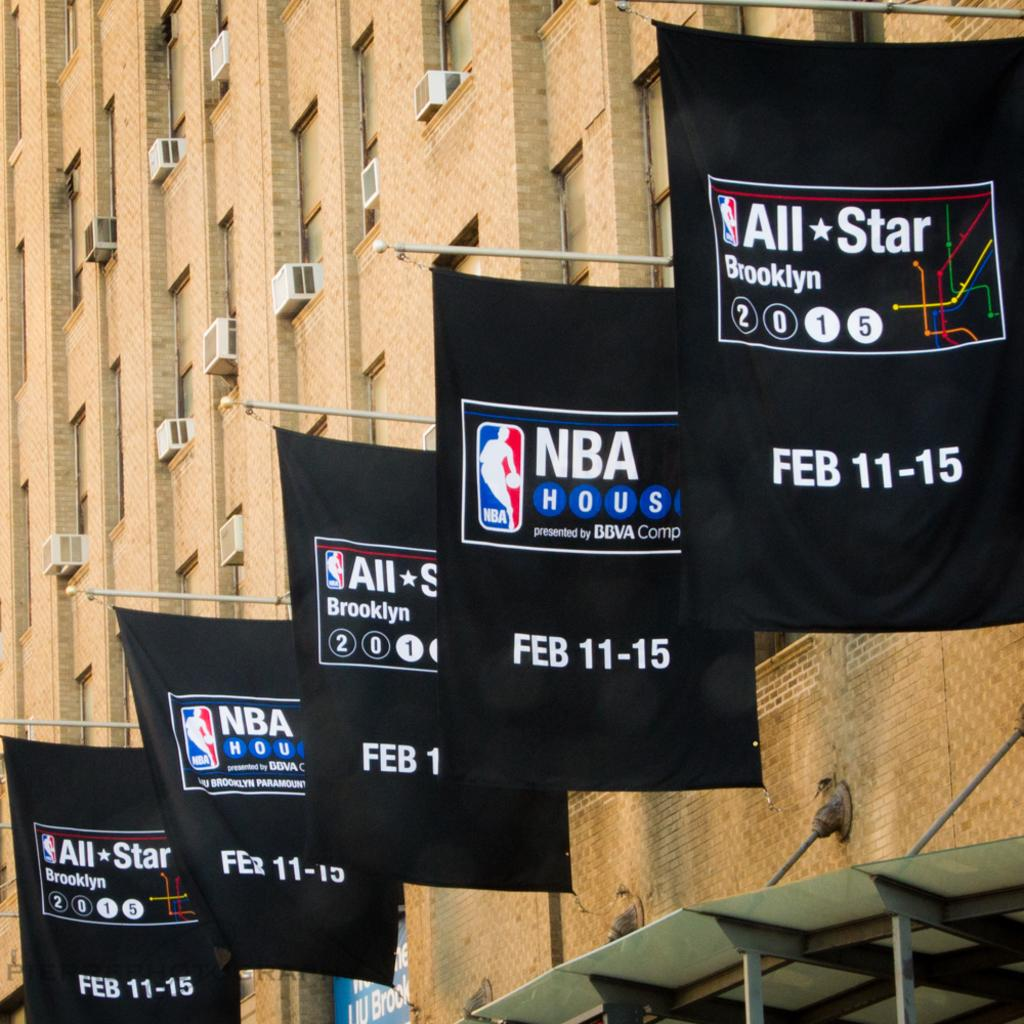What type of structure is the main subject in the image? There is a tall building in the image. What can be seen hanging on the building? There are advertisement banners hanging on the building. What type of equipment is visible in the image? AC compressors are visible in the image. Where are the ants crawling on the building in the image? There are no ants present in the image. What type of veil is draped over the AC compressors in the image? There is no veil present in the image; only AC compressors are visible. 